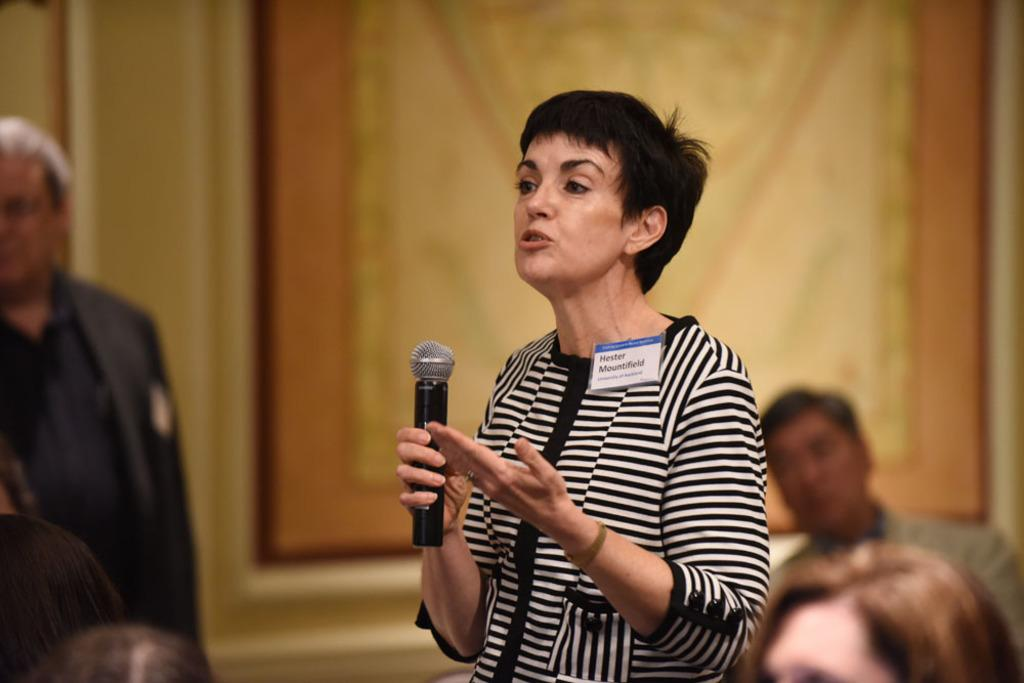Who is the main subject in the image? There is a woman in the image. What is the woman doing in the image? The woman is talking into a microphone. Are there any other people present in the image? Yes, there are people in the image. What are the people doing in the image? The people are listening to the woman. What color is the crayon being used by the woman in the image? There is no crayon present in the image. Is the woman in the image swimming? The image does not depict the woman swimming; she is talking into a microphone. 